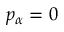Convert formula to latex. <formula><loc_0><loc_0><loc_500><loc_500>p _ { \alpha } = 0</formula> 